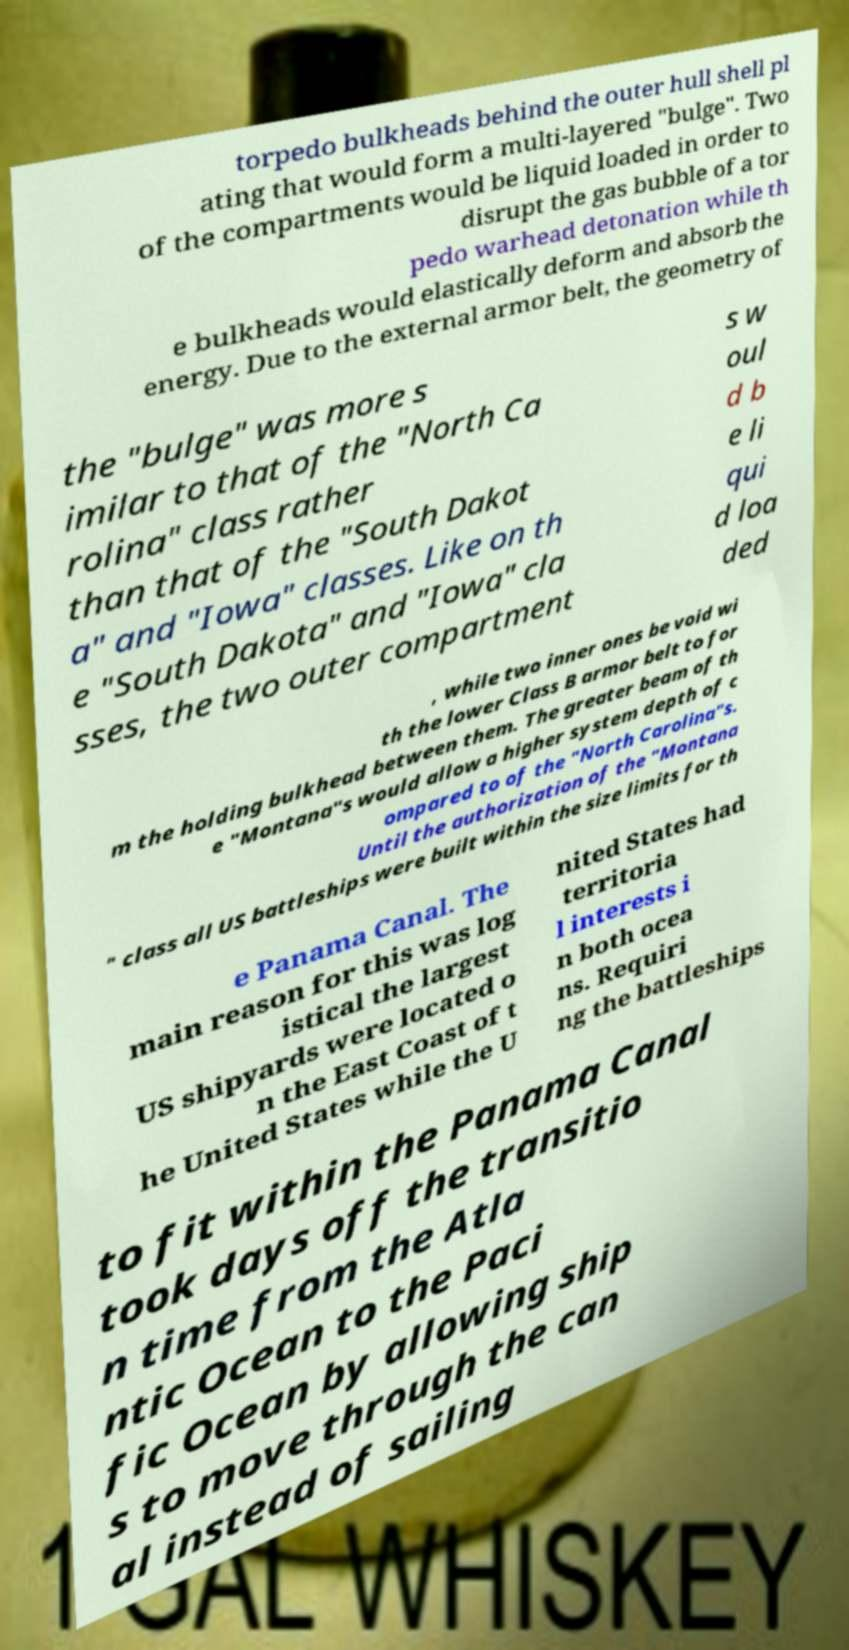Can you accurately transcribe the text from the provided image for me? torpedo bulkheads behind the outer hull shell pl ating that would form a multi-layered "bulge". Two of the compartments would be liquid loaded in order to disrupt the gas bubble of a tor pedo warhead detonation while th e bulkheads would elastically deform and absorb the energy. Due to the external armor belt, the geometry of the "bulge" was more s imilar to that of the "North Ca rolina" class rather than that of the "South Dakot a" and "Iowa" classes. Like on th e "South Dakota" and "Iowa" cla sses, the two outer compartment s w oul d b e li qui d loa ded , while two inner ones be void wi th the lower Class B armor belt to for m the holding bulkhead between them. The greater beam of th e "Montana"s would allow a higher system depth of c ompared to of the "North Carolina"s. Until the authorization of the "Montana " class all US battleships were built within the size limits for th e Panama Canal. The main reason for this was log istical the largest US shipyards were located o n the East Coast of t he United States while the U nited States had territoria l interests i n both ocea ns. Requiri ng the battleships to fit within the Panama Canal took days off the transitio n time from the Atla ntic Ocean to the Paci fic Ocean by allowing ship s to move through the can al instead of sailing 